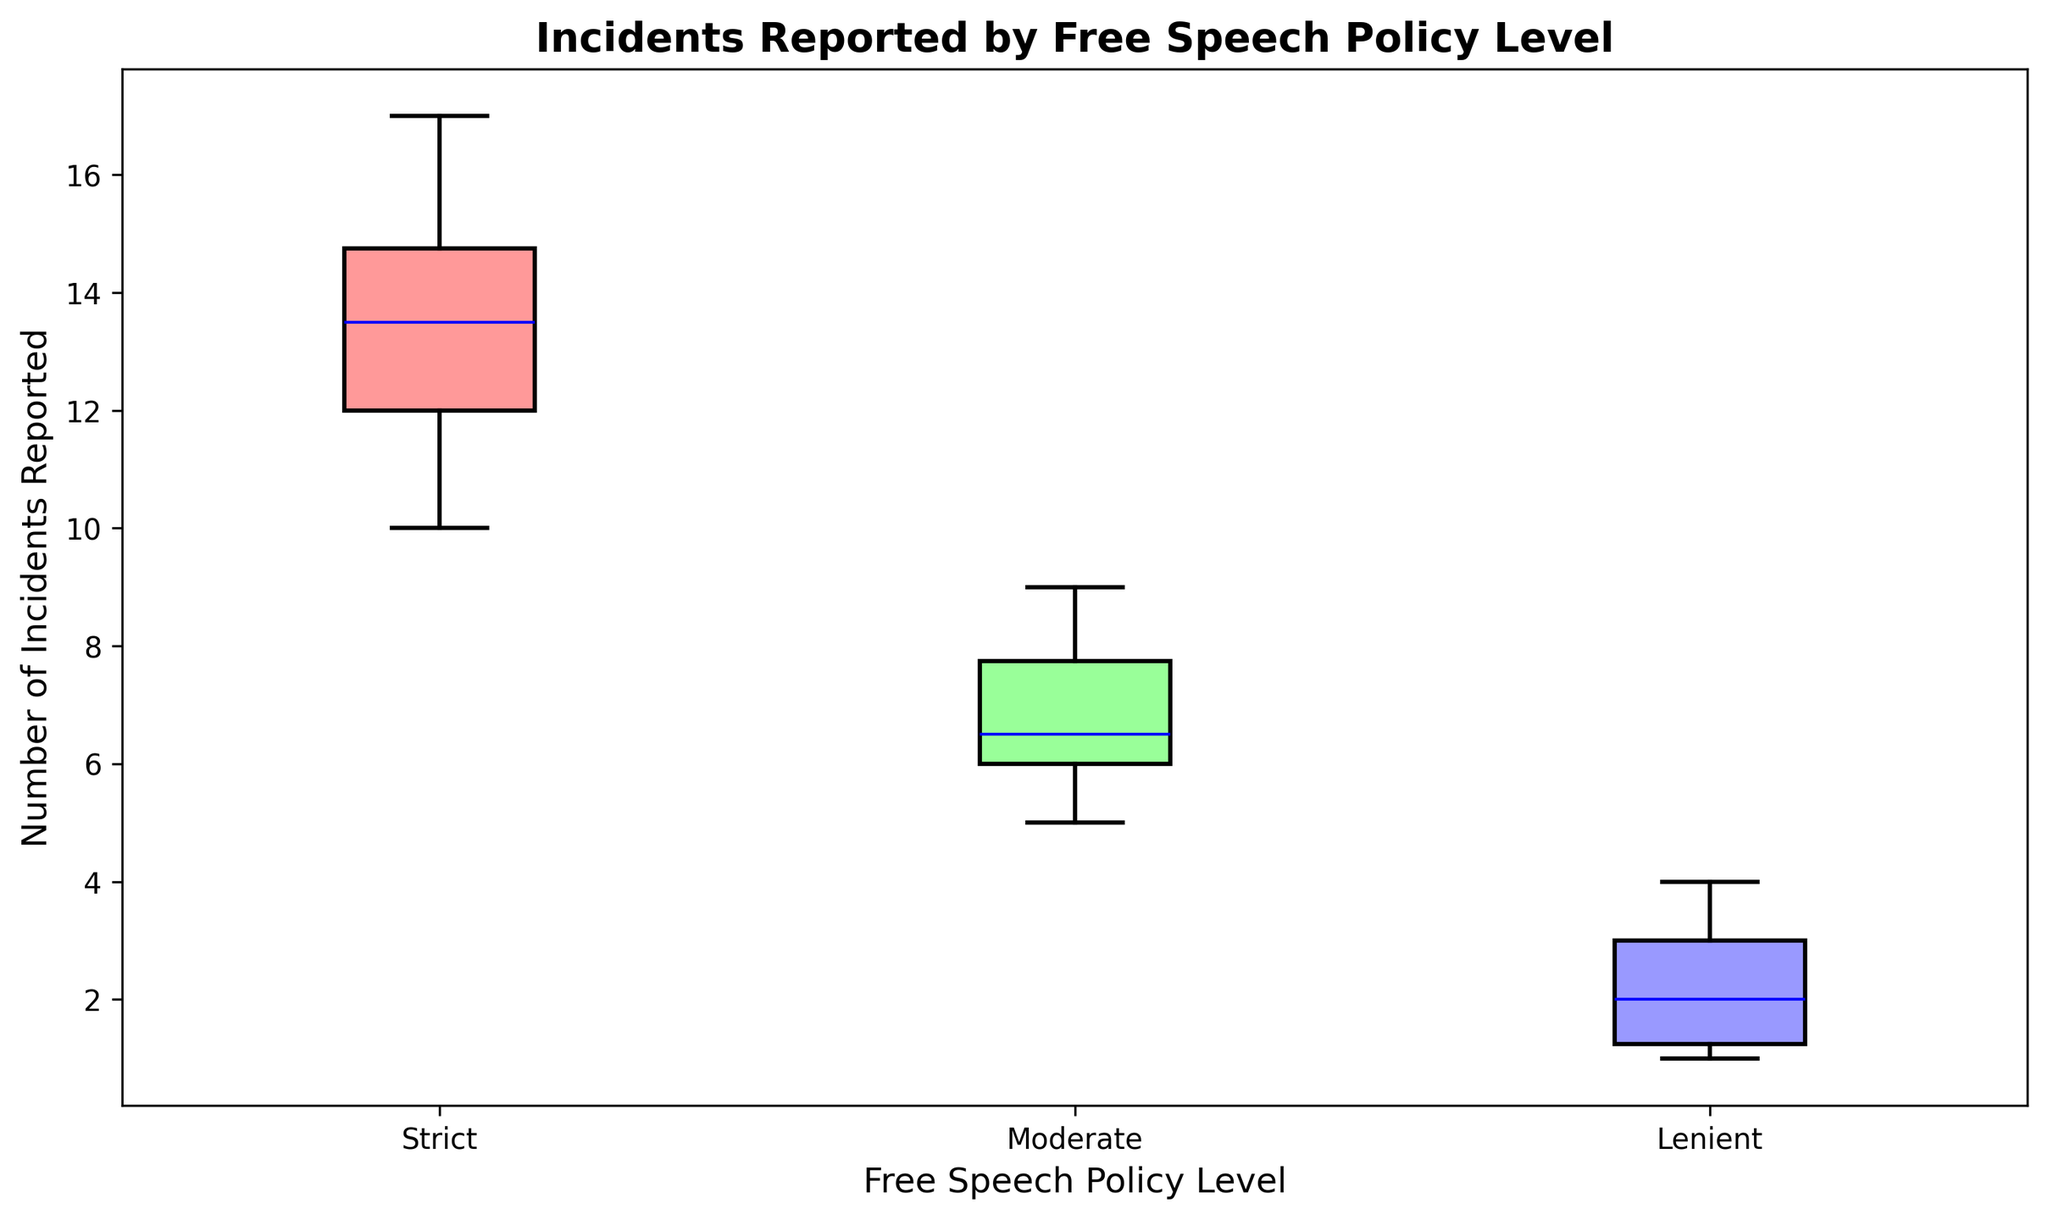What is the median number of incidents reported for universities with a strict free speech policy? Identify the box corresponding to the strict policy. The median is marked by the horizontal line inside the box.
Answer: 13 Which policy level has the lowest median number of incidents reported? Compare the horizontal lines representing the medians for the strict, moderate, and lenient policy levels. The lenient policy has the lowest median.
Answer: Lenient What is the interquartile range (IQR) for the number of incidents reported at universities with moderate free speech policies? The IQR is the range between the lower quartile (bottom of the box) and the upper quartile (top of the box). Identify these values from the moderate policy box and subtract the lower quartile from the upper quartile.
Answer: 3 (8 - 5) How does the spread of reported incidents vary between strict and lenient policy levels? Compare the length of the boxes and the whiskers for the strict and lenient policies. The strict policy has a larger spread, indicated by a taller box and longer whiskers.
Answer: Strict policy has a larger spread Which policy level exhibits the highest variability in the number of reported incidents? Variability can be inferred from the length of the box and whiskers. The strict policy level shows the highest variability with a taller box and longer whiskers.
Answer: Strict How many incidents were reported at the upper quartile for universities with a lenient policy? Identify the top of the box for the lenient policy level, which represents the upper quartile.
Answer: 3 Is the median number of reported incidents for moderate policy universities greater than that of lenient policy universities? Compare the horizontal lines inside the boxes for the moderate and lenient policies. The moderate policy median is higher.
Answer: Yes What is the range of reported incidents for universities with a lenient free speech policy? The range is determined by subtracting the minimum value (bottom whisker) from the maximum value (top whisker) for the lenient policy level.
Answer: 3 (4 - 1) Which policy level shows the smallest vertical spread between the lower and upper quartiles? Look for the shortest box among the strict, moderate, and lenient policy levels. The box for the lenient policy is the shortest.
Answer: Lenient How many incidents were reported at the lower quartile for universities with a strict policy? Identify the bottom of the box for the strict policy level, which represents the lower quartile.
Answer: 11 